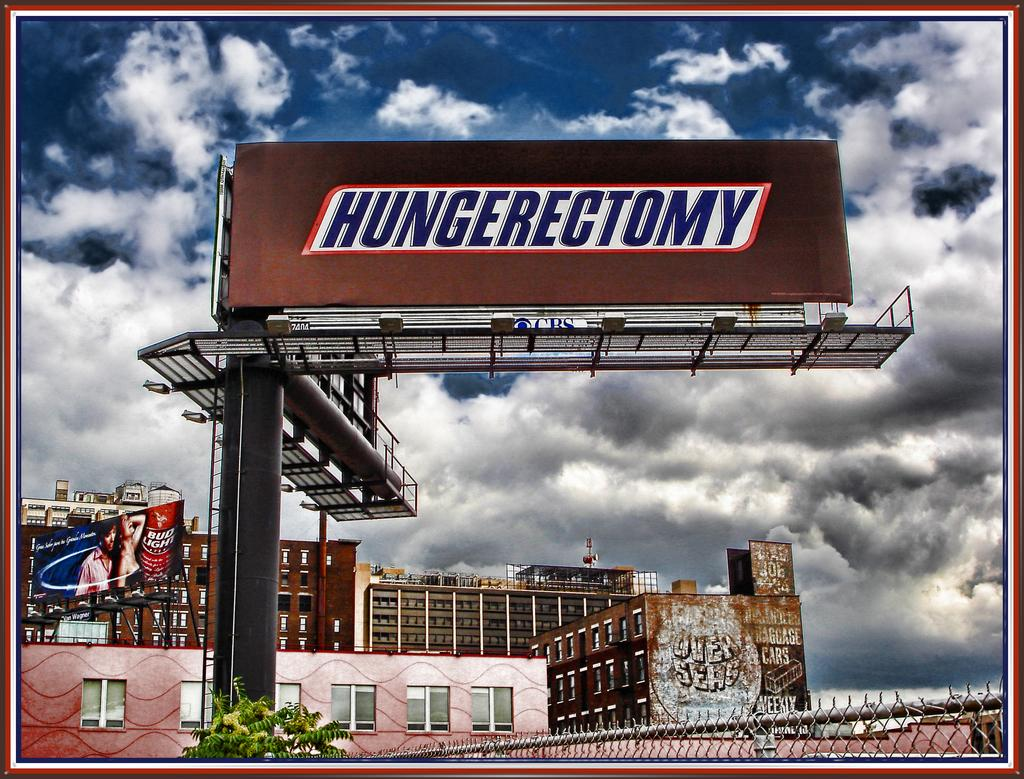<image>
Create a compact narrative representing the image presented. A billboard shows something that looks like a Snickers candy bar but with the word Hungerectomy instead of the candy name. 